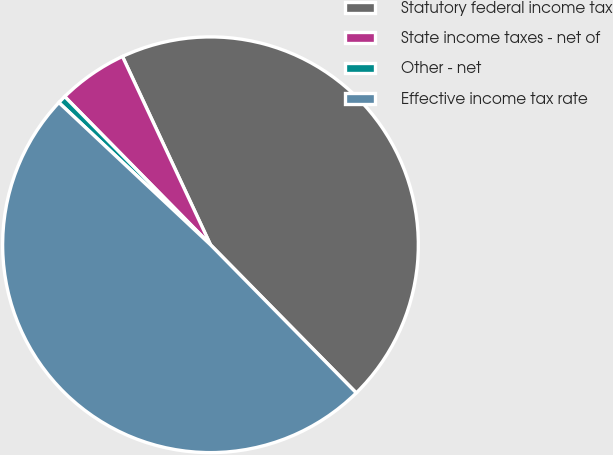Convert chart to OTSL. <chart><loc_0><loc_0><loc_500><loc_500><pie_chart><fcel>Statutory federal income tax<fcel>State income taxes - net of<fcel>Other - net<fcel>Effective income tax rate<nl><fcel>44.59%<fcel>5.41%<fcel>0.64%<fcel>49.36%<nl></chart> 